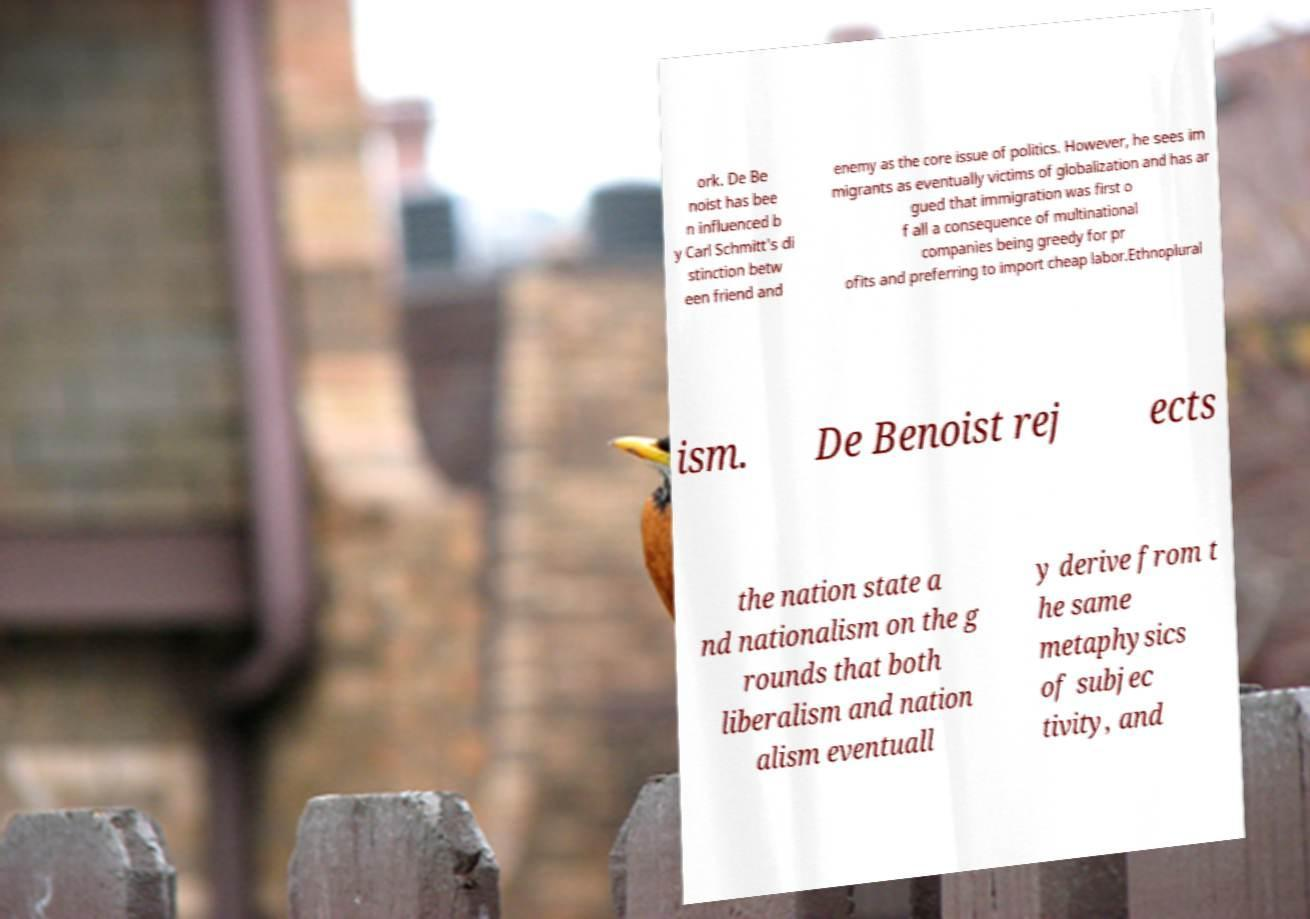For documentation purposes, I need the text within this image transcribed. Could you provide that? ork. De Be noist has bee n influenced b y Carl Schmitt's di stinction betw een friend and enemy as the core issue of politics. However, he sees im migrants as eventually victims of globalization and has ar gued that immigration was first o f all a consequence of multinational companies being greedy for pr ofits and preferring to import cheap labor.Ethnoplural ism. De Benoist rej ects the nation state a nd nationalism on the g rounds that both liberalism and nation alism eventuall y derive from t he same metaphysics of subjec tivity, and 